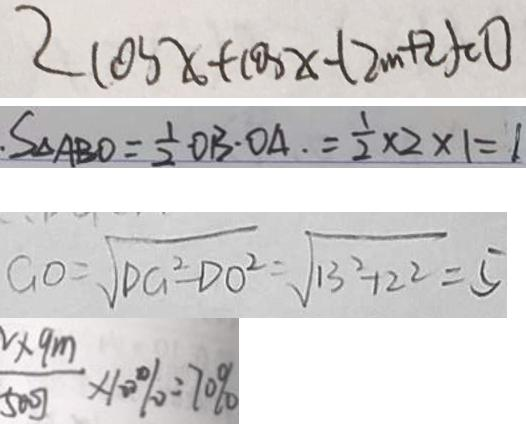Convert formula to latex. <formula><loc_0><loc_0><loc_500><loc_500>2 \cos x + \cos x - ( 2 m + 2 ) = 0 
 S _ { \Delta A B O } = \frac { 1 } { 2 } O B \cdot O A = \frac { 1 } { 2 } \times 2 \times 1 = 1 
 G O = \sqrt { D G ^ { 2 } - D O ^ { 2 } } = \sqrt { 1 3 ^ { 2 } - 1 2 ^ { 2 } } = 5 
 \frac { \times 9 m } { 5 0 0 J } \times 1 0 0 \% = 7 0 \%</formula> 